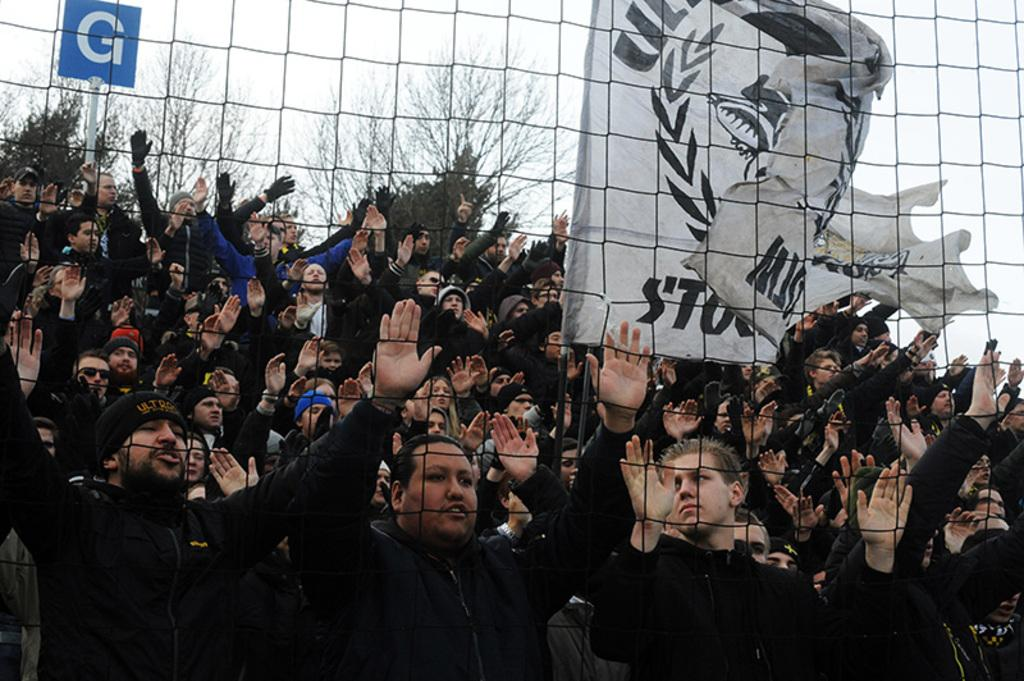What is happening in the image? There are people standing in the image. Can you describe the attire of some of the people? Some people are wearing caps. What can be seen in the background of the image? There are trees, a board, and a flag in the background of the image. What type of material is visible in the image? There is mesh visible in the image. Can you see any friends or bears interacting with the people in the image? There are no friends or bears present in the image; it only features people, trees, a board, a flag, and mesh. 